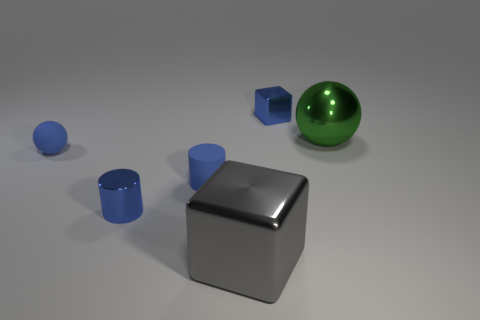There is a ball that is the same color as the matte cylinder; what is its size?
Provide a short and direct response. Small. There is a tiny shiny thing that is the same color as the metallic cylinder; what shape is it?
Provide a short and direct response. Cube. Is the number of large metallic blocks right of the gray shiny cube less than the number of large gray blocks that are behind the blue rubber cylinder?
Provide a short and direct response. No. There is a tiny metallic object that is in front of the shiny object that is behind the green object; what is its shape?
Ensure brevity in your answer.  Cylinder. Is there any other thing that has the same color as the rubber cylinder?
Keep it short and to the point. Yes. Is the tiny metal cylinder the same color as the large ball?
Make the answer very short. No. How many brown objects are either tiny matte objects or blocks?
Offer a terse response. 0. Are there fewer metallic things behind the large gray object than small red metallic balls?
Keep it short and to the point. No. How many big things are on the right side of the small shiny thing that is to the right of the big gray block?
Your response must be concise. 1. How many other objects are there of the same size as the blue ball?
Make the answer very short. 3. 